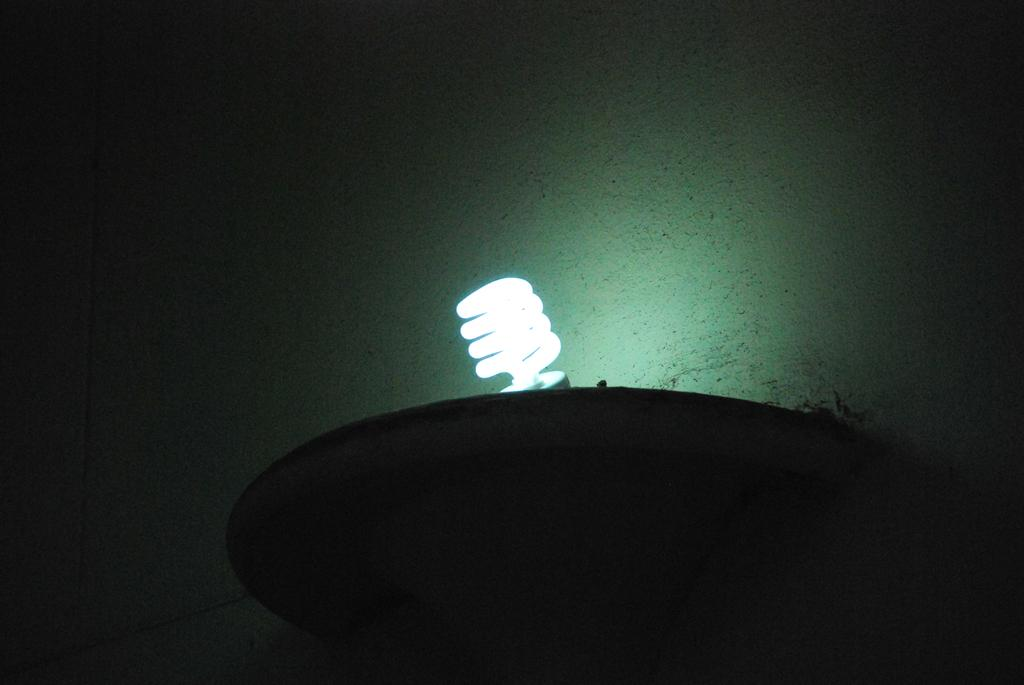What is the main object in the image? There is a light bulb in the image. Are there any other objects present in the image? Yes, there are other objects in the image. What can be seen in the background of the image? There is a wall in the background of the image. What is the tax rate on the light bulb in the image? There is no information about tax rates in the image, as it only shows a light bulb and other objects. 